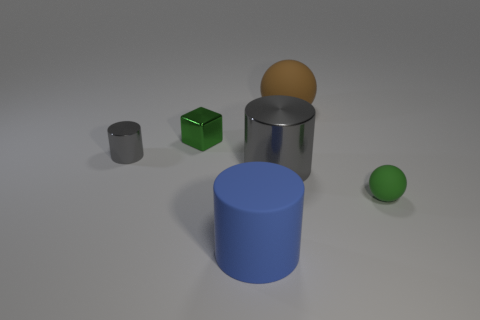Add 1 big blue metallic blocks. How many objects exist? 7 Subtract all spheres. How many objects are left? 4 Subtract 0 brown blocks. How many objects are left? 6 Subtract all brown things. Subtract all big rubber balls. How many objects are left? 4 Add 5 big matte balls. How many big matte balls are left? 6 Add 5 matte objects. How many matte objects exist? 8 